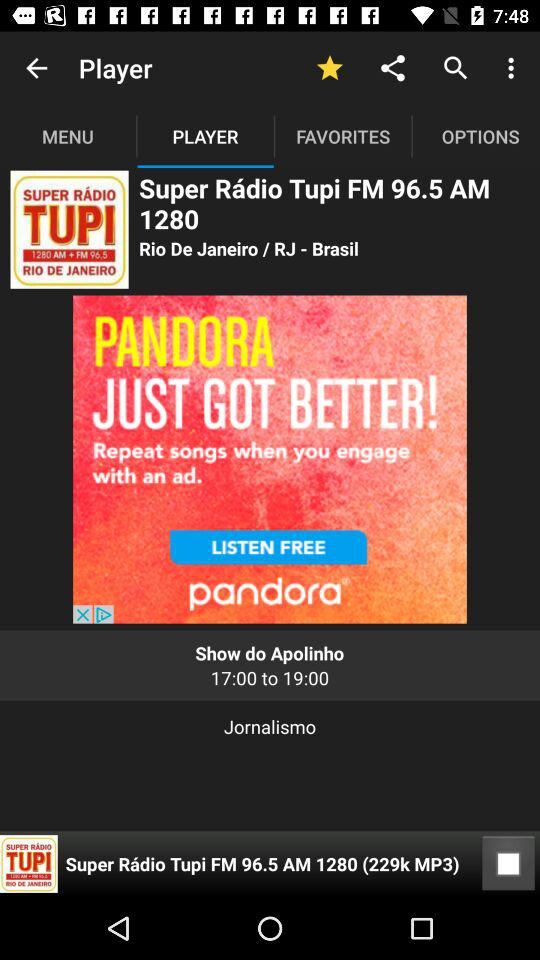What is the size of the mp3 file playing in the player?
When the provided information is insufficient, respond with <no answer>. <no answer> 